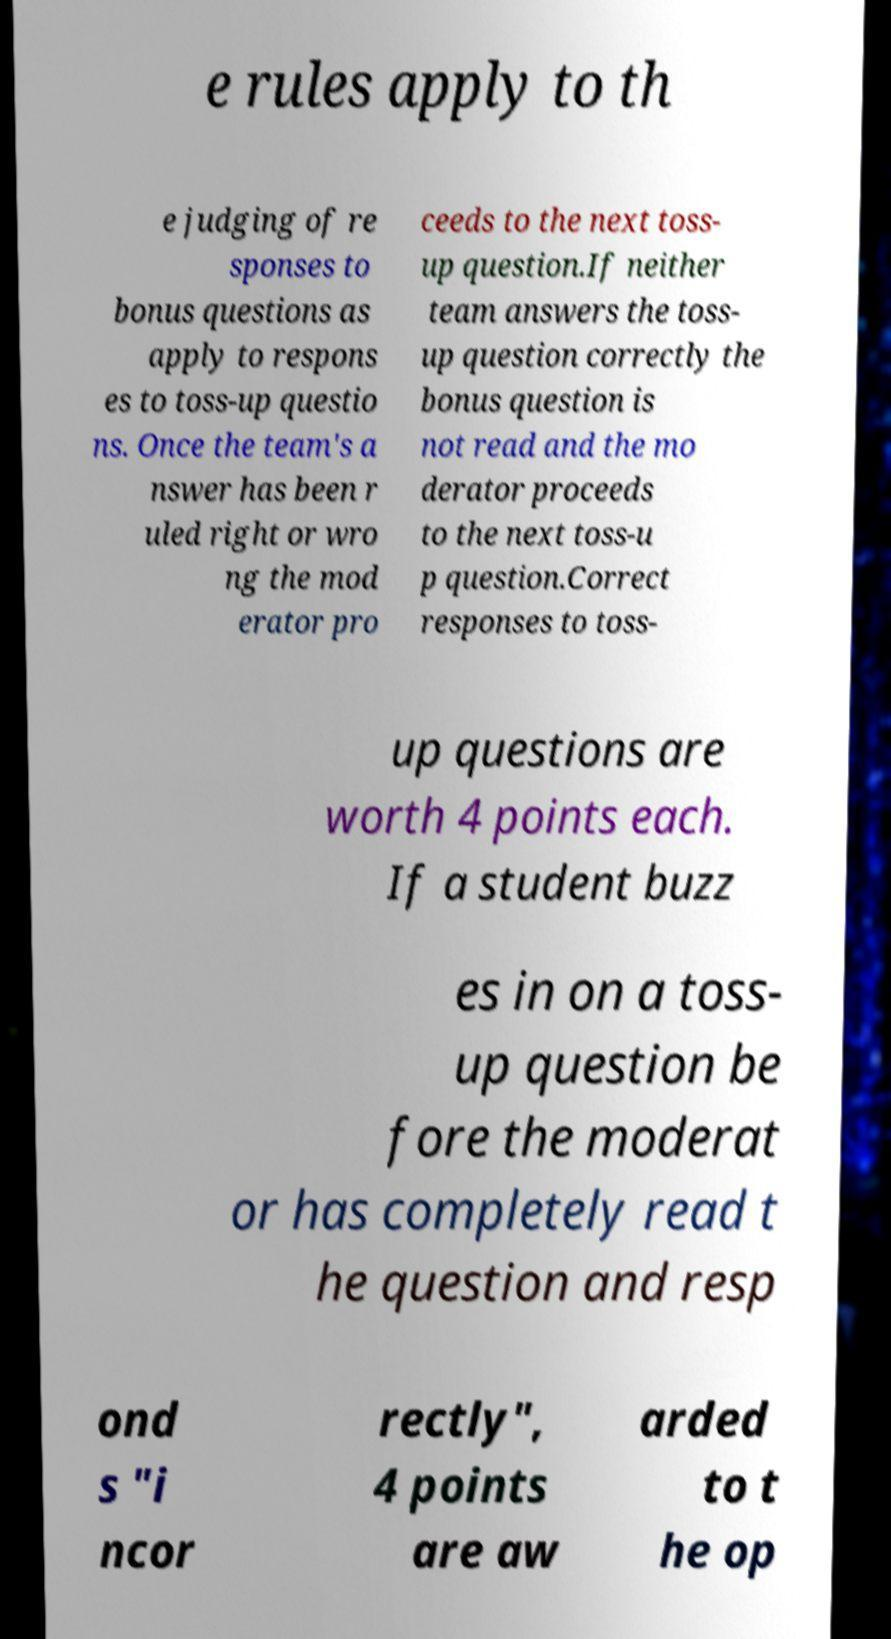Could you extract and type out the text from this image? e rules apply to th e judging of re sponses to bonus questions as apply to respons es to toss-up questio ns. Once the team's a nswer has been r uled right or wro ng the mod erator pro ceeds to the next toss- up question.If neither team answers the toss- up question correctly the bonus question is not read and the mo derator proceeds to the next toss-u p question.Correct responses to toss- up questions are worth 4 points each. If a student buzz es in on a toss- up question be fore the moderat or has completely read t he question and resp ond s "i ncor rectly", 4 points are aw arded to t he op 